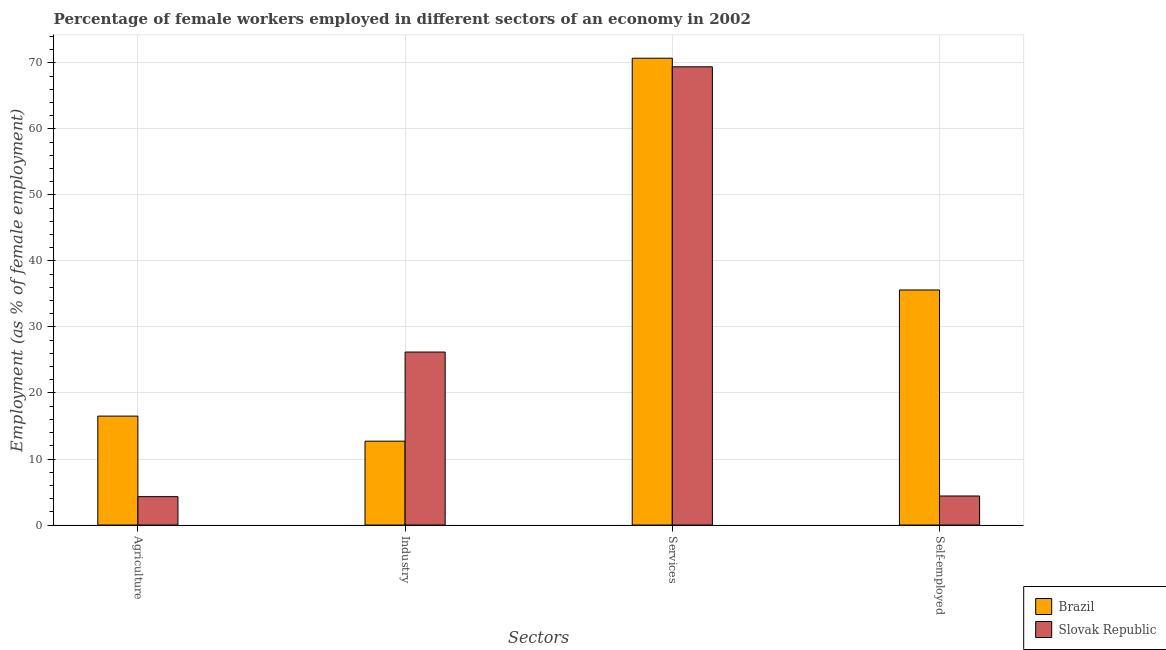How many different coloured bars are there?
Provide a short and direct response. 2. How many groups of bars are there?
Offer a very short reply. 4. How many bars are there on the 4th tick from the left?
Keep it short and to the point. 2. What is the label of the 1st group of bars from the left?
Keep it short and to the point. Agriculture. What is the percentage of self employed female workers in Brazil?
Your response must be concise. 35.6. Across all countries, what is the maximum percentage of female workers in services?
Your response must be concise. 70.7. Across all countries, what is the minimum percentage of female workers in industry?
Your response must be concise. 12.7. In which country was the percentage of female workers in services minimum?
Your answer should be very brief. Slovak Republic. What is the total percentage of self employed female workers in the graph?
Offer a terse response. 40. What is the difference between the percentage of female workers in services in Brazil and that in Slovak Republic?
Your answer should be very brief. 1.3. What is the difference between the percentage of female workers in agriculture in Slovak Republic and the percentage of female workers in industry in Brazil?
Give a very brief answer. -8.4. What is the average percentage of female workers in agriculture per country?
Offer a terse response. 10.4. What is the difference between the percentage of female workers in agriculture and percentage of self employed female workers in Brazil?
Give a very brief answer. -19.1. What is the ratio of the percentage of female workers in services in Brazil to that in Slovak Republic?
Provide a short and direct response. 1.02. Is the percentage of female workers in industry in Slovak Republic less than that in Brazil?
Offer a very short reply. No. Is the difference between the percentage of self employed female workers in Brazil and Slovak Republic greater than the difference between the percentage of female workers in industry in Brazil and Slovak Republic?
Your answer should be compact. Yes. What is the difference between the highest and the second highest percentage of female workers in industry?
Provide a succinct answer. 13.5. What is the difference between the highest and the lowest percentage of self employed female workers?
Offer a terse response. 31.2. In how many countries, is the percentage of female workers in services greater than the average percentage of female workers in services taken over all countries?
Give a very brief answer. 1. Is the sum of the percentage of female workers in agriculture in Slovak Republic and Brazil greater than the maximum percentage of self employed female workers across all countries?
Your answer should be very brief. No. What does the 2nd bar from the left in Agriculture represents?
Provide a short and direct response. Slovak Republic. What does the 1st bar from the right in Self-employed represents?
Offer a terse response. Slovak Republic. Is it the case that in every country, the sum of the percentage of female workers in agriculture and percentage of female workers in industry is greater than the percentage of female workers in services?
Your answer should be compact. No. How many bars are there?
Make the answer very short. 8. How many countries are there in the graph?
Provide a succinct answer. 2. Are the values on the major ticks of Y-axis written in scientific E-notation?
Ensure brevity in your answer.  No. Does the graph contain any zero values?
Provide a succinct answer. No. Does the graph contain grids?
Provide a succinct answer. Yes. Where does the legend appear in the graph?
Your answer should be very brief. Bottom right. How many legend labels are there?
Offer a very short reply. 2. How are the legend labels stacked?
Provide a succinct answer. Vertical. What is the title of the graph?
Provide a short and direct response. Percentage of female workers employed in different sectors of an economy in 2002. Does "Qatar" appear as one of the legend labels in the graph?
Provide a succinct answer. No. What is the label or title of the X-axis?
Provide a short and direct response. Sectors. What is the label or title of the Y-axis?
Your answer should be compact. Employment (as % of female employment). What is the Employment (as % of female employment) in Brazil in Agriculture?
Offer a very short reply. 16.5. What is the Employment (as % of female employment) of Slovak Republic in Agriculture?
Your response must be concise. 4.3. What is the Employment (as % of female employment) of Brazil in Industry?
Your response must be concise. 12.7. What is the Employment (as % of female employment) in Slovak Republic in Industry?
Your answer should be very brief. 26.2. What is the Employment (as % of female employment) of Brazil in Services?
Ensure brevity in your answer.  70.7. What is the Employment (as % of female employment) in Slovak Republic in Services?
Make the answer very short. 69.4. What is the Employment (as % of female employment) of Brazil in Self-employed?
Provide a short and direct response. 35.6. What is the Employment (as % of female employment) in Slovak Republic in Self-employed?
Provide a short and direct response. 4.4. Across all Sectors, what is the maximum Employment (as % of female employment) of Brazil?
Ensure brevity in your answer.  70.7. Across all Sectors, what is the maximum Employment (as % of female employment) in Slovak Republic?
Offer a terse response. 69.4. Across all Sectors, what is the minimum Employment (as % of female employment) in Brazil?
Keep it short and to the point. 12.7. Across all Sectors, what is the minimum Employment (as % of female employment) in Slovak Republic?
Offer a very short reply. 4.3. What is the total Employment (as % of female employment) in Brazil in the graph?
Give a very brief answer. 135.5. What is the total Employment (as % of female employment) in Slovak Republic in the graph?
Give a very brief answer. 104.3. What is the difference between the Employment (as % of female employment) of Brazil in Agriculture and that in Industry?
Ensure brevity in your answer.  3.8. What is the difference between the Employment (as % of female employment) in Slovak Republic in Agriculture and that in Industry?
Make the answer very short. -21.9. What is the difference between the Employment (as % of female employment) in Brazil in Agriculture and that in Services?
Your answer should be very brief. -54.2. What is the difference between the Employment (as % of female employment) in Slovak Republic in Agriculture and that in Services?
Offer a terse response. -65.1. What is the difference between the Employment (as % of female employment) in Brazil in Agriculture and that in Self-employed?
Keep it short and to the point. -19.1. What is the difference between the Employment (as % of female employment) in Slovak Republic in Agriculture and that in Self-employed?
Your answer should be compact. -0.1. What is the difference between the Employment (as % of female employment) in Brazil in Industry and that in Services?
Your answer should be compact. -58. What is the difference between the Employment (as % of female employment) of Slovak Republic in Industry and that in Services?
Make the answer very short. -43.2. What is the difference between the Employment (as % of female employment) of Brazil in Industry and that in Self-employed?
Keep it short and to the point. -22.9. What is the difference between the Employment (as % of female employment) in Slovak Republic in Industry and that in Self-employed?
Your answer should be compact. 21.8. What is the difference between the Employment (as % of female employment) of Brazil in Services and that in Self-employed?
Offer a very short reply. 35.1. What is the difference between the Employment (as % of female employment) in Slovak Republic in Services and that in Self-employed?
Your answer should be compact. 65. What is the difference between the Employment (as % of female employment) in Brazil in Agriculture and the Employment (as % of female employment) in Slovak Republic in Industry?
Provide a succinct answer. -9.7. What is the difference between the Employment (as % of female employment) of Brazil in Agriculture and the Employment (as % of female employment) of Slovak Republic in Services?
Give a very brief answer. -52.9. What is the difference between the Employment (as % of female employment) in Brazil in Industry and the Employment (as % of female employment) in Slovak Republic in Services?
Keep it short and to the point. -56.7. What is the difference between the Employment (as % of female employment) in Brazil in Services and the Employment (as % of female employment) in Slovak Republic in Self-employed?
Your answer should be very brief. 66.3. What is the average Employment (as % of female employment) of Brazil per Sectors?
Make the answer very short. 33.88. What is the average Employment (as % of female employment) in Slovak Republic per Sectors?
Provide a succinct answer. 26.07. What is the difference between the Employment (as % of female employment) in Brazil and Employment (as % of female employment) in Slovak Republic in Industry?
Your response must be concise. -13.5. What is the difference between the Employment (as % of female employment) of Brazil and Employment (as % of female employment) of Slovak Republic in Services?
Offer a very short reply. 1.3. What is the difference between the Employment (as % of female employment) in Brazil and Employment (as % of female employment) in Slovak Republic in Self-employed?
Keep it short and to the point. 31.2. What is the ratio of the Employment (as % of female employment) in Brazil in Agriculture to that in Industry?
Your answer should be very brief. 1.3. What is the ratio of the Employment (as % of female employment) of Slovak Republic in Agriculture to that in Industry?
Offer a terse response. 0.16. What is the ratio of the Employment (as % of female employment) in Brazil in Agriculture to that in Services?
Your response must be concise. 0.23. What is the ratio of the Employment (as % of female employment) of Slovak Republic in Agriculture to that in Services?
Your answer should be compact. 0.06. What is the ratio of the Employment (as % of female employment) of Brazil in Agriculture to that in Self-employed?
Offer a terse response. 0.46. What is the ratio of the Employment (as % of female employment) in Slovak Republic in Agriculture to that in Self-employed?
Your answer should be very brief. 0.98. What is the ratio of the Employment (as % of female employment) of Brazil in Industry to that in Services?
Your answer should be compact. 0.18. What is the ratio of the Employment (as % of female employment) of Slovak Republic in Industry to that in Services?
Give a very brief answer. 0.38. What is the ratio of the Employment (as % of female employment) in Brazil in Industry to that in Self-employed?
Provide a succinct answer. 0.36. What is the ratio of the Employment (as % of female employment) in Slovak Republic in Industry to that in Self-employed?
Offer a terse response. 5.95. What is the ratio of the Employment (as % of female employment) of Brazil in Services to that in Self-employed?
Provide a succinct answer. 1.99. What is the ratio of the Employment (as % of female employment) of Slovak Republic in Services to that in Self-employed?
Offer a very short reply. 15.77. What is the difference between the highest and the second highest Employment (as % of female employment) in Brazil?
Ensure brevity in your answer.  35.1. What is the difference between the highest and the second highest Employment (as % of female employment) in Slovak Republic?
Your response must be concise. 43.2. What is the difference between the highest and the lowest Employment (as % of female employment) in Slovak Republic?
Give a very brief answer. 65.1. 